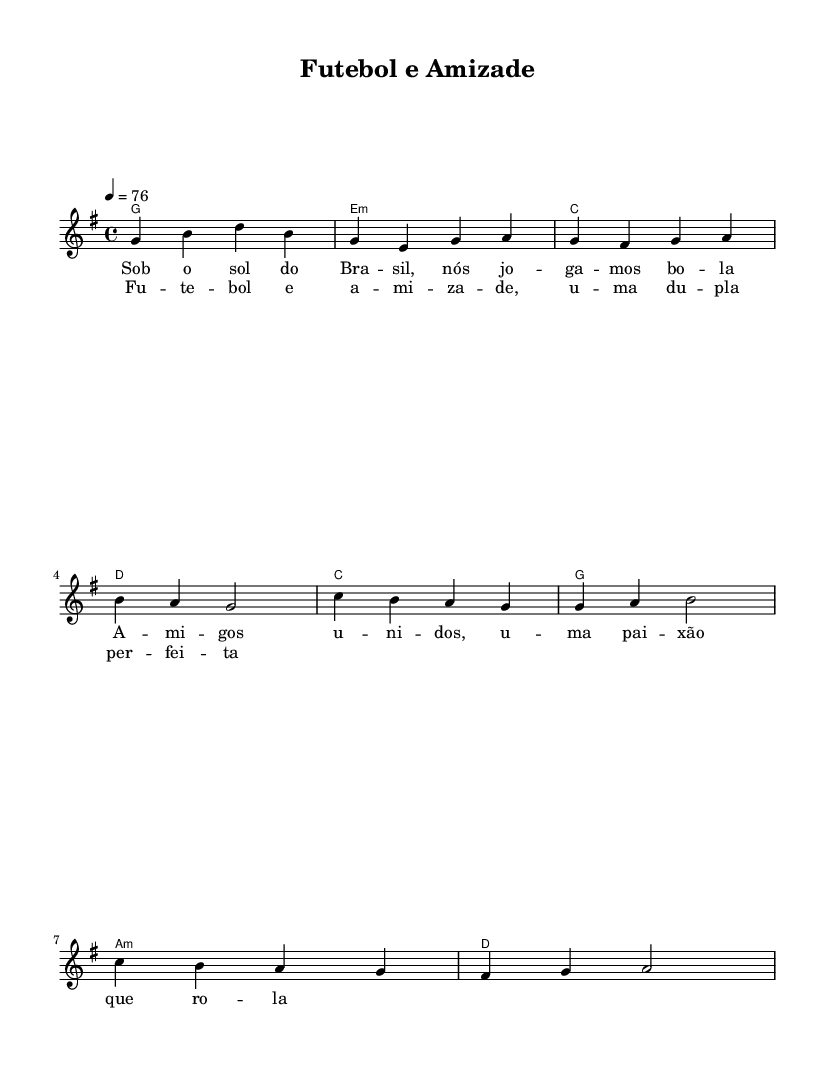What is the key signature of this music? The key signature indicated at the beginning of the piece is G major, which contains one sharp (F#). This is visible from the key signature notation next to the clef symbol.
Answer: G major What is the time signature of this music? The time signature is shown at the beginning of the score as 4/4. This means there are four beats in each measure and the quarter note gets one beat.
Answer: 4/4 What is the tempo marking for this piece? The tempo is indicated as 4 = 76, which means there are 76 quarter note beats per minute. This is visible below the staff.
Answer: 76 What chords are used in the verse? The chords listed for the verse are G, E minor, C, and D. They are written in the chord names section corresponding to the measures in the verse.
Answer: G, E minor, C, D What type of lyrics accompany the chorus? The lyrics of the chorus focus on themes of football and friendship, characteristic of modern country rock ballads that often explore personal relationships. This can be deduced from the lyrics section aligned with the chorus.
Answer: Football and friendship How many measures are in the chorus? The chorus has four measures, which can be counted from the notation in the score. The chord symbols and melody notes indicate four distinct rhythmic patterns.
Answer: 4 What is the overall theme of this piece? The overall theme reflects the joys of football and the solidarity of friendship, which is common in country rock songs about teenage experiences and relationships. This can be inferred from the lyrics content.
Answer: Football and friendship 